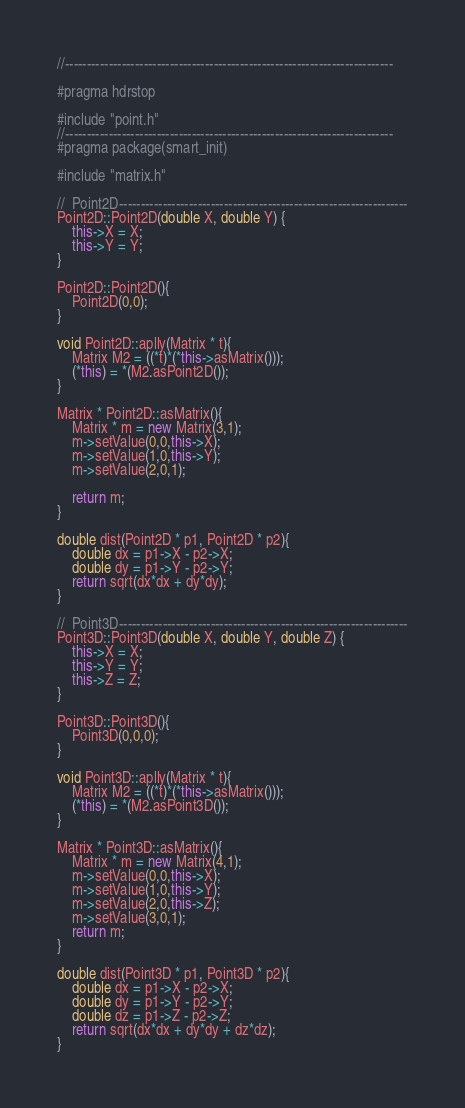Convert code to text. <code><loc_0><loc_0><loc_500><loc_500><_C++_>//---------------------------------------------------------------------------

#pragma hdrstop

#include "point.h"
//---------------------------------------------------------------------------
#pragma package(smart_init)

#include "matrix.h"

//	Point2D------------------------------------------------------------------
Point2D::Point2D(double X, double Y) {
	this->X = X;
	this->Y = Y;
}

Point2D::Point2D(){
	Point2D(0,0);
}

void Point2D::aplly(Matrix * t){
	Matrix M2 = ((*t)*(*this->asMatrix()));
	(*this) = *(M2.asPoint2D());
}

Matrix * Point2D::asMatrix(){
	Matrix * m = new Matrix(3,1);
	m->setValue(0,0,this->X);
	m->setValue(1,0,this->Y);
	m->setValue(2,0,1);
	
	return m;
}

double dist(Point2D * p1, Point2D * p2){
	double dx = p1->X - p2->X;
	double dy = p1->Y - p2->Y;
	return sqrt(dx*dx + dy*dy);
}

//	Point3D------------------------------------------------------------------
Point3D::Point3D(double X, double Y, double Z) {
	this->X = X;
	this->Y = Y;
    this->Z = Z;
}

Point3D::Point3D(){
	Point3D(0,0,0);
}

void Point3D::aplly(Matrix * t){
	Matrix M2 = ((*t)*(*this->asMatrix()));
	(*this) = *(M2.asPoint3D());
}

Matrix * Point3D::asMatrix(){
	Matrix * m = new Matrix(4,1);
	m->setValue(0,0,this->X);
	m->setValue(1,0,this->Y);
	m->setValue(2,0,this->Z);	
	m->setValue(3,0,1);	
	return m;
}

double dist(Point3D * p1, Point3D * p2){
	double dx = p1->X - p2->X;
	double dy = p1->Y - p2->Y;
    double dz = p1->Z - p2->Z;
	return sqrt(dx*dx + dy*dy + dz*dz);
}
</code> 